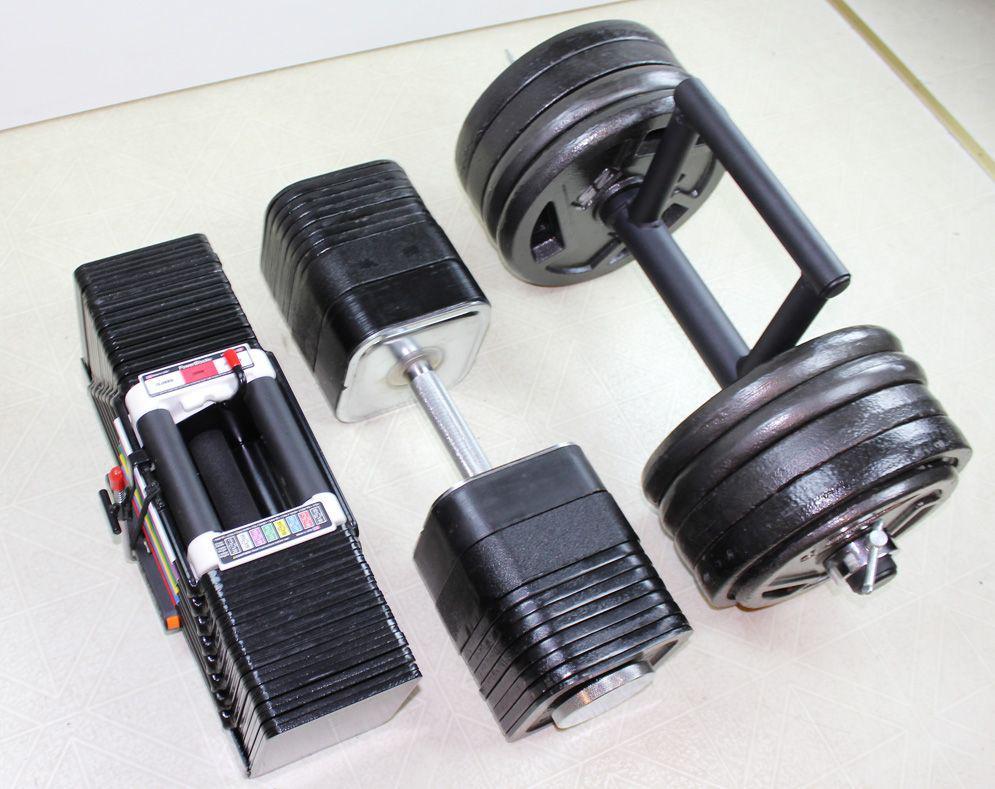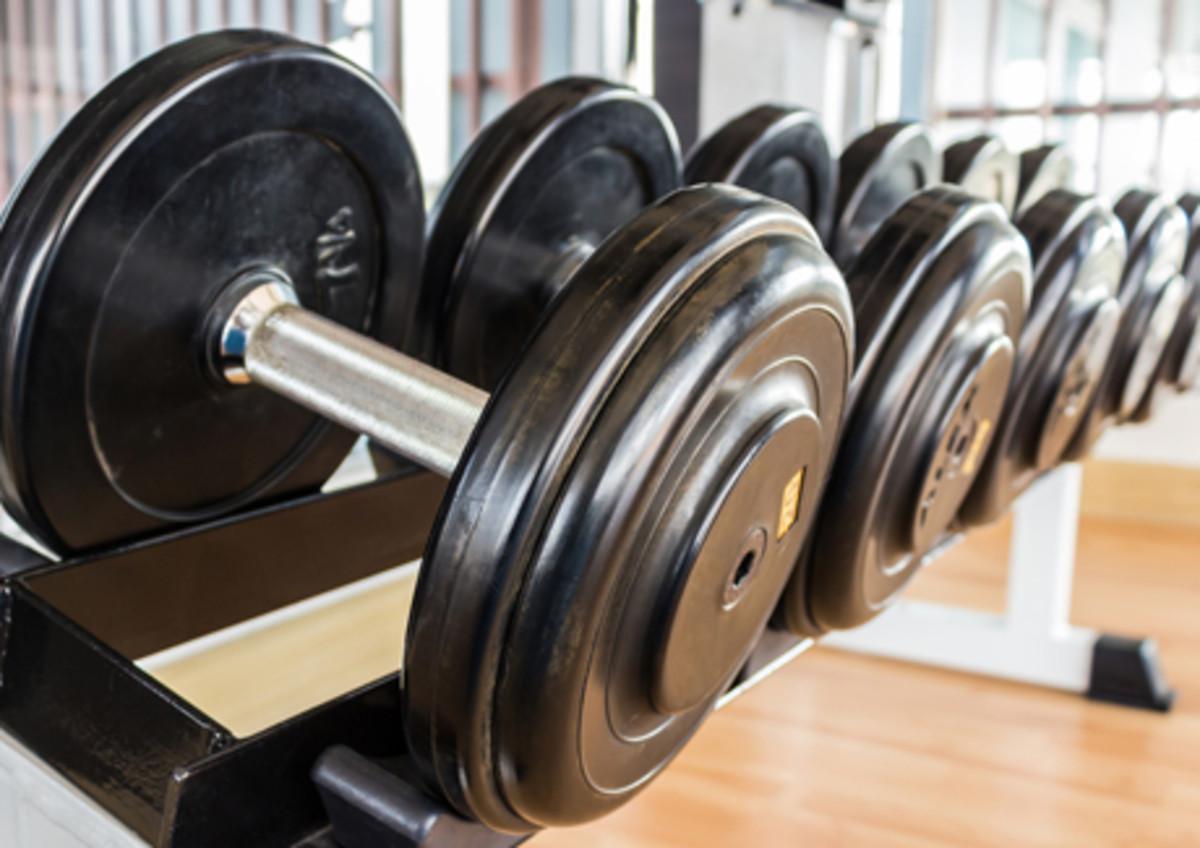The first image is the image on the left, the second image is the image on the right. Assess this claim about the two images: "One image shows a row of at least four black barbells on a black rack.". Correct or not? Answer yes or no. Yes. The first image is the image on the left, the second image is the image on the right. Considering the images on both sides, is "In one of the images, there is an assembled dumbbell with extra plates next to it." valid? Answer yes or no. No. 